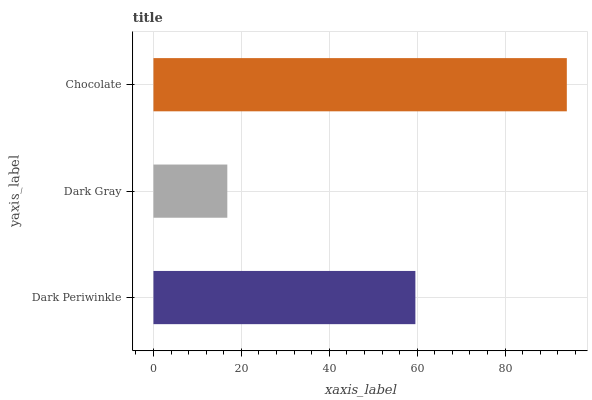Is Dark Gray the minimum?
Answer yes or no. Yes. Is Chocolate the maximum?
Answer yes or no. Yes. Is Chocolate the minimum?
Answer yes or no. No. Is Dark Gray the maximum?
Answer yes or no. No. Is Chocolate greater than Dark Gray?
Answer yes or no. Yes. Is Dark Gray less than Chocolate?
Answer yes or no. Yes. Is Dark Gray greater than Chocolate?
Answer yes or no. No. Is Chocolate less than Dark Gray?
Answer yes or no. No. Is Dark Periwinkle the high median?
Answer yes or no. Yes. Is Dark Periwinkle the low median?
Answer yes or no. Yes. Is Dark Gray the high median?
Answer yes or no. No. Is Chocolate the low median?
Answer yes or no. No. 